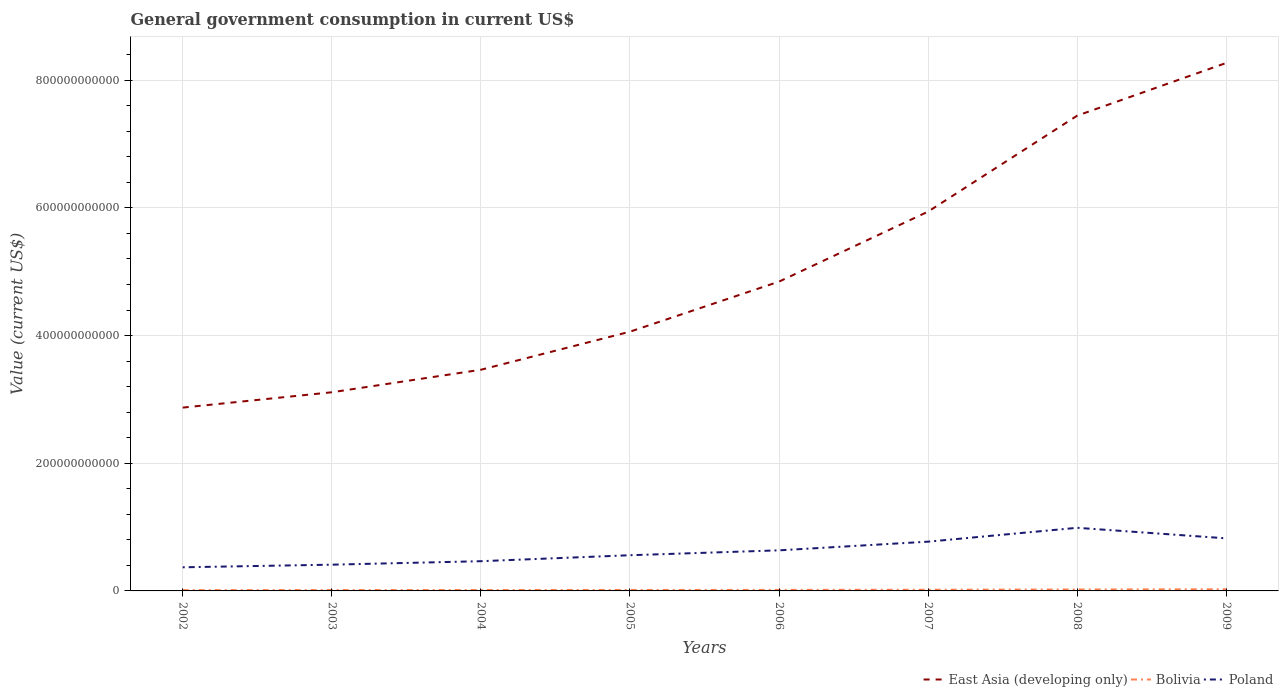Does the line corresponding to Poland intersect with the line corresponding to East Asia (developing only)?
Provide a succinct answer. No. Is the number of lines equal to the number of legend labels?
Your answer should be very brief. Yes. Across all years, what is the maximum government conusmption in East Asia (developing only)?
Your answer should be compact. 2.87e+11. What is the total government conusmption in Poland in the graph?
Provide a short and direct response. -1.89e+1. What is the difference between the highest and the second highest government conusmption in Poland?
Make the answer very short. 6.19e+1. How many years are there in the graph?
Offer a terse response. 8. What is the difference between two consecutive major ticks on the Y-axis?
Offer a terse response. 2.00e+11. Does the graph contain any zero values?
Provide a succinct answer. No. Does the graph contain grids?
Provide a succinct answer. Yes. Where does the legend appear in the graph?
Your answer should be compact. Bottom right. What is the title of the graph?
Offer a very short reply. General government consumption in current US$. Does "Guam" appear as one of the legend labels in the graph?
Offer a terse response. No. What is the label or title of the X-axis?
Provide a succinct answer. Years. What is the label or title of the Y-axis?
Your answer should be very brief. Value (current US$). What is the Value (current US$) in East Asia (developing only) in 2002?
Your answer should be very brief. 2.87e+11. What is the Value (current US$) of Bolivia in 2002?
Keep it short and to the point. 1.26e+09. What is the Value (current US$) in Poland in 2002?
Ensure brevity in your answer.  3.70e+1. What is the Value (current US$) in East Asia (developing only) in 2003?
Your answer should be compact. 3.11e+11. What is the Value (current US$) of Bolivia in 2003?
Give a very brief answer. 1.34e+09. What is the Value (current US$) of Poland in 2003?
Your answer should be compact. 4.11e+1. What is the Value (current US$) in East Asia (developing only) in 2004?
Keep it short and to the point. 3.46e+11. What is the Value (current US$) in Bolivia in 2004?
Your answer should be compact. 1.43e+09. What is the Value (current US$) of Poland in 2004?
Ensure brevity in your answer.  4.66e+1. What is the Value (current US$) in East Asia (developing only) in 2005?
Offer a terse response. 4.06e+11. What is the Value (current US$) of Bolivia in 2005?
Provide a short and direct response. 1.53e+09. What is the Value (current US$) of Poland in 2005?
Offer a very short reply. 5.59e+1. What is the Value (current US$) of East Asia (developing only) in 2006?
Make the answer very short. 4.85e+11. What is the Value (current US$) in Bolivia in 2006?
Provide a short and direct response. 1.64e+09. What is the Value (current US$) in Poland in 2006?
Provide a short and direct response. 6.36e+1. What is the Value (current US$) of East Asia (developing only) in 2007?
Give a very brief answer. 5.94e+11. What is the Value (current US$) of Bolivia in 2007?
Provide a short and direct response. 1.84e+09. What is the Value (current US$) in Poland in 2007?
Make the answer very short. 7.72e+1. What is the Value (current US$) in East Asia (developing only) in 2008?
Keep it short and to the point. 7.45e+11. What is the Value (current US$) of Bolivia in 2008?
Provide a short and direct response. 2.21e+09. What is the Value (current US$) in Poland in 2008?
Ensure brevity in your answer.  9.89e+1. What is the Value (current US$) in East Asia (developing only) in 2009?
Ensure brevity in your answer.  8.27e+11. What is the Value (current US$) of Bolivia in 2009?
Give a very brief answer. 2.55e+09. What is the Value (current US$) of Poland in 2009?
Keep it short and to the point. 8.24e+1. Across all years, what is the maximum Value (current US$) of East Asia (developing only)?
Make the answer very short. 8.27e+11. Across all years, what is the maximum Value (current US$) in Bolivia?
Ensure brevity in your answer.  2.55e+09. Across all years, what is the maximum Value (current US$) of Poland?
Give a very brief answer. 9.89e+1. Across all years, what is the minimum Value (current US$) of East Asia (developing only)?
Give a very brief answer. 2.87e+11. Across all years, what is the minimum Value (current US$) in Bolivia?
Offer a very short reply. 1.26e+09. Across all years, what is the minimum Value (current US$) of Poland?
Give a very brief answer. 3.70e+1. What is the total Value (current US$) in East Asia (developing only) in the graph?
Your answer should be very brief. 4.00e+12. What is the total Value (current US$) in Bolivia in the graph?
Give a very brief answer. 1.38e+1. What is the total Value (current US$) in Poland in the graph?
Ensure brevity in your answer.  5.03e+11. What is the difference between the Value (current US$) of East Asia (developing only) in 2002 and that in 2003?
Ensure brevity in your answer.  -2.40e+1. What is the difference between the Value (current US$) of Bolivia in 2002 and that in 2003?
Give a very brief answer. -7.30e+07. What is the difference between the Value (current US$) of Poland in 2002 and that in 2003?
Your answer should be compact. -4.10e+09. What is the difference between the Value (current US$) of East Asia (developing only) in 2002 and that in 2004?
Offer a terse response. -5.93e+1. What is the difference between the Value (current US$) in Bolivia in 2002 and that in 2004?
Make the answer very short. -1.64e+08. What is the difference between the Value (current US$) of Poland in 2002 and that in 2004?
Make the answer very short. -9.54e+09. What is the difference between the Value (current US$) in East Asia (developing only) in 2002 and that in 2005?
Offer a terse response. -1.19e+11. What is the difference between the Value (current US$) of Bolivia in 2002 and that in 2005?
Your answer should be compact. -2.63e+08. What is the difference between the Value (current US$) of Poland in 2002 and that in 2005?
Your answer should be compact. -1.89e+1. What is the difference between the Value (current US$) in East Asia (developing only) in 2002 and that in 2006?
Make the answer very short. -1.97e+11. What is the difference between the Value (current US$) in Bolivia in 2002 and that in 2006?
Make the answer very short. -3.81e+08. What is the difference between the Value (current US$) in Poland in 2002 and that in 2006?
Keep it short and to the point. -2.66e+1. What is the difference between the Value (current US$) of East Asia (developing only) in 2002 and that in 2007?
Your response must be concise. -3.07e+11. What is the difference between the Value (current US$) in Bolivia in 2002 and that in 2007?
Give a very brief answer. -5.82e+08. What is the difference between the Value (current US$) of Poland in 2002 and that in 2007?
Keep it short and to the point. -4.02e+1. What is the difference between the Value (current US$) of East Asia (developing only) in 2002 and that in 2008?
Your answer should be compact. -4.57e+11. What is the difference between the Value (current US$) in Bolivia in 2002 and that in 2008?
Provide a succinct answer. -9.52e+08. What is the difference between the Value (current US$) of Poland in 2002 and that in 2008?
Give a very brief answer. -6.19e+1. What is the difference between the Value (current US$) in East Asia (developing only) in 2002 and that in 2009?
Keep it short and to the point. -5.40e+11. What is the difference between the Value (current US$) in Bolivia in 2002 and that in 2009?
Keep it short and to the point. -1.29e+09. What is the difference between the Value (current US$) of Poland in 2002 and that in 2009?
Offer a very short reply. -4.53e+1. What is the difference between the Value (current US$) of East Asia (developing only) in 2003 and that in 2004?
Your answer should be very brief. -3.53e+1. What is the difference between the Value (current US$) in Bolivia in 2003 and that in 2004?
Offer a very short reply. -9.11e+07. What is the difference between the Value (current US$) of Poland in 2003 and that in 2004?
Provide a succinct answer. -5.44e+09. What is the difference between the Value (current US$) in East Asia (developing only) in 2003 and that in 2005?
Your answer should be compact. -9.49e+1. What is the difference between the Value (current US$) of Bolivia in 2003 and that in 2005?
Your response must be concise. -1.90e+08. What is the difference between the Value (current US$) of Poland in 2003 and that in 2005?
Provide a short and direct response. -1.48e+1. What is the difference between the Value (current US$) in East Asia (developing only) in 2003 and that in 2006?
Your response must be concise. -1.73e+11. What is the difference between the Value (current US$) in Bolivia in 2003 and that in 2006?
Your response must be concise. -3.09e+08. What is the difference between the Value (current US$) in Poland in 2003 and that in 2006?
Keep it short and to the point. -2.25e+1. What is the difference between the Value (current US$) in East Asia (developing only) in 2003 and that in 2007?
Ensure brevity in your answer.  -2.83e+11. What is the difference between the Value (current US$) in Bolivia in 2003 and that in 2007?
Make the answer very short. -5.09e+08. What is the difference between the Value (current US$) of Poland in 2003 and that in 2007?
Offer a very short reply. -3.61e+1. What is the difference between the Value (current US$) in East Asia (developing only) in 2003 and that in 2008?
Offer a terse response. -4.33e+11. What is the difference between the Value (current US$) in Bolivia in 2003 and that in 2008?
Keep it short and to the point. -8.79e+08. What is the difference between the Value (current US$) in Poland in 2003 and that in 2008?
Your response must be concise. -5.78e+1. What is the difference between the Value (current US$) in East Asia (developing only) in 2003 and that in 2009?
Provide a succinct answer. -5.16e+11. What is the difference between the Value (current US$) of Bolivia in 2003 and that in 2009?
Give a very brief answer. -1.22e+09. What is the difference between the Value (current US$) in Poland in 2003 and that in 2009?
Make the answer very short. -4.12e+1. What is the difference between the Value (current US$) in East Asia (developing only) in 2004 and that in 2005?
Your response must be concise. -5.97e+1. What is the difference between the Value (current US$) of Bolivia in 2004 and that in 2005?
Keep it short and to the point. -9.90e+07. What is the difference between the Value (current US$) in Poland in 2004 and that in 2005?
Provide a short and direct response. -9.35e+09. What is the difference between the Value (current US$) of East Asia (developing only) in 2004 and that in 2006?
Offer a very short reply. -1.38e+11. What is the difference between the Value (current US$) in Bolivia in 2004 and that in 2006?
Your response must be concise. -2.17e+08. What is the difference between the Value (current US$) of Poland in 2004 and that in 2006?
Provide a succinct answer. -1.70e+1. What is the difference between the Value (current US$) of East Asia (developing only) in 2004 and that in 2007?
Make the answer very short. -2.48e+11. What is the difference between the Value (current US$) in Bolivia in 2004 and that in 2007?
Your answer should be very brief. -4.18e+08. What is the difference between the Value (current US$) in Poland in 2004 and that in 2007?
Your answer should be very brief. -3.06e+1. What is the difference between the Value (current US$) of East Asia (developing only) in 2004 and that in 2008?
Provide a short and direct response. -3.98e+11. What is the difference between the Value (current US$) of Bolivia in 2004 and that in 2008?
Your answer should be very brief. -7.87e+08. What is the difference between the Value (current US$) in Poland in 2004 and that in 2008?
Make the answer very short. -5.23e+1. What is the difference between the Value (current US$) in East Asia (developing only) in 2004 and that in 2009?
Provide a succinct answer. -4.81e+11. What is the difference between the Value (current US$) in Bolivia in 2004 and that in 2009?
Your answer should be compact. -1.12e+09. What is the difference between the Value (current US$) in Poland in 2004 and that in 2009?
Make the answer very short. -3.58e+1. What is the difference between the Value (current US$) in East Asia (developing only) in 2005 and that in 2006?
Provide a short and direct response. -7.84e+1. What is the difference between the Value (current US$) of Bolivia in 2005 and that in 2006?
Keep it short and to the point. -1.18e+08. What is the difference between the Value (current US$) in Poland in 2005 and that in 2006?
Your answer should be compact. -7.67e+09. What is the difference between the Value (current US$) in East Asia (developing only) in 2005 and that in 2007?
Provide a short and direct response. -1.88e+11. What is the difference between the Value (current US$) in Bolivia in 2005 and that in 2007?
Your answer should be compact. -3.19e+08. What is the difference between the Value (current US$) in Poland in 2005 and that in 2007?
Your response must be concise. -2.13e+1. What is the difference between the Value (current US$) of East Asia (developing only) in 2005 and that in 2008?
Offer a very short reply. -3.38e+11. What is the difference between the Value (current US$) in Bolivia in 2005 and that in 2008?
Your response must be concise. -6.88e+08. What is the difference between the Value (current US$) of Poland in 2005 and that in 2008?
Give a very brief answer. -4.30e+1. What is the difference between the Value (current US$) in East Asia (developing only) in 2005 and that in 2009?
Provide a short and direct response. -4.21e+11. What is the difference between the Value (current US$) in Bolivia in 2005 and that in 2009?
Provide a short and direct response. -1.03e+09. What is the difference between the Value (current US$) in Poland in 2005 and that in 2009?
Offer a very short reply. -2.64e+1. What is the difference between the Value (current US$) of East Asia (developing only) in 2006 and that in 2007?
Ensure brevity in your answer.  -1.10e+11. What is the difference between the Value (current US$) of Bolivia in 2006 and that in 2007?
Provide a short and direct response. -2.01e+08. What is the difference between the Value (current US$) of Poland in 2006 and that in 2007?
Your answer should be compact. -1.36e+1. What is the difference between the Value (current US$) of East Asia (developing only) in 2006 and that in 2008?
Give a very brief answer. -2.60e+11. What is the difference between the Value (current US$) in Bolivia in 2006 and that in 2008?
Offer a very short reply. -5.70e+08. What is the difference between the Value (current US$) of Poland in 2006 and that in 2008?
Offer a terse response. -3.53e+1. What is the difference between the Value (current US$) in East Asia (developing only) in 2006 and that in 2009?
Give a very brief answer. -3.43e+11. What is the difference between the Value (current US$) of Bolivia in 2006 and that in 2009?
Provide a succinct answer. -9.07e+08. What is the difference between the Value (current US$) of Poland in 2006 and that in 2009?
Offer a terse response. -1.88e+1. What is the difference between the Value (current US$) in East Asia (developing only) in 2007 and that in 2008?
Make the answer very short. -1.50e+11. What is the difference between the Value (current US$) of Bolivia in 2007 and that in 2008?
Ensure brevity in your answer.  -3.69e+08. What is the difference between the Value (current US$) in Poland in 2007 and that in 2008?
Your answer should be compact. -2.17e+1. What is the difference between the Value (current US$) in East Asia (developing only) in 2007 and that in 2009?
Give a very brief answer. -2.33e+11. What is the difference between the Value (current US$) of Bolivia in 2007 and that in 2009?
Give a very brief answer. -7.06e+08. What is the difference between the Value (current US$) of Poland in 2007 and that in 2009?
Offer a terse response. -5.18e+09. What is the difference between the Value (current US$) in East Asia (developing only) in 2008 and that in 2009?
Give a very brief answer. -8.26e+1. What is the difference between the Value (current US$) of Bolivia in 2008 and that in 2009?
Give a very brief answer. -3.37e+08. What is the difference between the Value (current US$) in Poland in 2008 and that in 2009?
Make the answer very short. 1.65e+1. What is the difference between the Value (current US$) of East Asia (developing only) in 2002 and the Value (current US$) of Bolivia in 2003?
Make the answer very short. 2.86e+11. What is the difference between the Value (current US$) in East Asia (developing only) in 2002 and the Value (current US$) in Poland in 2003?
Your response must be concise. 2.46e+11. What is the difference between the Value (current US$) in Bolivia in 2002 and the Value (current US$) in Poland in 2003?
Offer a terse response. -3.99e+1. What is the difference between the Value (current US$) in East Asia (developing only) in 2002 and the Value (current US$) in Bolivia in 2004?
Ensure brevity in your answer.  2.86e+11. What is the difference between the Value (current US$) of East Asia (developing only) in 2002 and the Value (current US$) of Poland in 2004?
Offer a very short reply. 2.41e+11. What is the difference between the Value (current US$) in Bolivia in 2002 and the Value (current US$) in Poland in 2004?
Provide a short and direct response. -4.53e+1. What is the difference between the Value (current US$) of East Asia (developing only) in 2002 and the Value (current US$) of Bolivia in 2005?
Your answer should be compact. 2.86e+11. What is the difference between the Value (current US$) in East Asia (developing only) in 2002 and the Value (current US$) in Poland in 2005?
Offer a terse response. 2.31e+11. What is the difference between the Value (current US$) in Bolivia in 2002 and the Value (current US$) in Poland in 2005?
Make the answer very short. -5.46e+1. What is the difference between the Value (current US$) in East Asia (developing only) in 2002 and the Value (current US$) in Bolivia in 2006?
Offer a terse response. 2.86e+11. What is the difference between the Value (current US$) of East Asia (developing only) in 2002 and the Value (current US$) of Poland in 2006?
Your answer should be compact. 2.24e+11. What is the difference between the Value (current US$) of Bolivia in 2002 and the Value (current US$) of Poland in 2006?
Offer a very short reply. -6.23e+1. What is the difference between the Value (current US$) of East Asia (developing only) in 2002 and the Value (current US$) of Bolivia in 2007?
Your answer should be compact. 2.85e+11. What is the difference between the Value (current US$) in East Asia (developing only) in 2002 and the Value (current US$) in Poland in 2007?
Keep it short and to the point. 2.10e+11. What is the difference between the Value (current US$) of Bolivia in 2002 and the Value (current US$) of Poland in 2007?
Provide a succinct answer. -7.59e+1. What is the difference between the Value (current US$) of East Asia (developing only) in 2002 and the Value (current US$) of Bolivia in 2008?
Provide a succinct answer. 2.85e+11. What is the difference between the Value (current US$) in East Asia (developing only) in 2002 and the Value (current US$) in Poland in 2008?
Provide a short and direct response. 1.88e+11. What is the difference between the Value (current US$) of Bolivia in 2002 and the Value (current US$) of Poland in 2008?
Give a very brief answer. -9.76e+1. What is the difference between the Value (current US$) of East Asia (developing only) in 2002 and the Value (current US$) of Bolivia in 2009?
Keep it short and to the point. 2.85e+11. What is the difference between the Value (current US$) in East Asia (developing only) in 2002 and the Value (current US$) in Poland in 2009?
Make the answer very short. 2.05e+11. What is the difference between the Value (current US$) in Bolivia in 2002 and the Value (current US$) in Poland in 2009?
Your response must be concise. -8.11e+1. What is the difference between the Value (current US$) in East Asia (developing only) in 2003 and the Value (current US$) in Bolivia in 2004?
Provide a short and direct response. 3.10e+11. What is the difference between the Value (current US$) of East Asia (developing only) in 2003 and the Value (current US$) of Poland in 2004?
Give a very brief answer. 2.65e+11. What is the difference between the Value (current US$) in Bolivia in 2003 and the Value (current US$) in Poland in 2004?
Your response must be concise. -4.52e+1. What is the difference between the Value (current US$) of East Asia (developing only) in 2003 and the Value (current US$) of Bolivia in 2005?
Your answer should be very brief. 3.10e+11. What is the difference between the Value (current US$) in East Asia (developing only) in 2003 and the Value (current US$) in Poland in 2005?
Give a very brief answer. 2.55e+11. What is the difference between the Value (current US$) in Bolivia in 2003 and the Value (current US$) in Poland in 2005?
Ensure brevity in your answer.  -5.46e+1. What is the difference between the Value (current US$) of East Asia (developing only) in 2003 and the Value (current US$) of Bolivia in 2006?
Give a very brief answer. 3.10e+11. What is the difference between the Value (current US$) in East Asia (developing only) in 2003 and the Value (current US$) in Poland in 2006?
Offer a terse response. 2.48e+11. What is the difference between the Value (current US$) of Bolivia in 2003 and the Value (current US$) of Poland in 2006?
Your response must be concise. -6.22e+1. What is the difference between the Value (current US$) in East Asia (developing only) in 2003 and the Value (current US$) in Bolivia in 2007?
Your answer should be compact. 3.09e+11. What is the difference between the Value (current US$) in East Asia (developing only) in 2003 and the Value (current US$) in Poland in 2007?
Your response must be concise. 2.34e+11. What is the difference between the Value (current US$) of Bolivia in 2003 and the Value (current US$) of Poland in 2007?
Provide a succinct answer. -7.58e+1. What is the difference between the Value (current US$) in East Asia (developing only) in 2003 and the Value (current US$) in Bolivia in 2008?
Provide a succinct answer. 3.09e+11. What is the difference between the Value (current US$) in East Asia (developing only) in 2003 and the Value (current US$) in Poland in 2008?
Provide a short and direct response. 2.12e+11. What is the difference between the Value (current US$) of Bolivia in 2003 and the Value (current US$) of Poland in 2008?
Your response must be concise. -9.75e+1. What is the difference between the Value (current US$) in East Asia (developing only) in 2003 and the Value (current US$) in Bolivia in 2009?
Offer a very short reply. 3.09e+11. What is the difference between the Value (current US$) in East Asia (developing only) in 2003 and the Value (current US$) in Poland in 2009?
Your response must be concise. 2.29e+11. What is the difference between the Value (current US$) of Bolivia in 2003 and the Value (current US$) of Poland in 2009?
Your response must be concise. -8.10e+1. What is the difference between the Value (current US$) in East Asia (developing only) in 2004 and the Value (current US$) in Bolivia in 2005?
Give a very brief answer. 3.45e+11. What is the difference between the Value (current US$) of East Asia (developing only) in 2004 and the Value (current US$) of Poland in 2005?
Offer a very short reply. 2.91e+11. What is the difference between the Value (current US$) of Bolivia in 2004 and the Value (current US$) of Poland in 2005?
Your answer should be compact. -5.45e+1. What is the difference between the Value (current US$) in East Asia (developing only) in 2004 and the Value (current US$) in Bolivia in 2006?
Ensure brevity in your answer.  3.45e+11. What is the difference between the Value (current US$) in East Asia (developing only) in 2004 and the Value (current US$) in Poland in 2006?
Offer a very short reply. 2.83e+11. What is the difference between the Value (current US$) in Bolivia in 2004 and the Value (current US$) in Poland in 2006?
Your response must be concise. -6.22e+1. What is the difference between the Value (current US$) of East Asia (developing only) in 2004 and the Value (current US$) of Bolivia in 2007?
Keep it short and to the point. 3.45e+11. What is the difference between the Value (current US$) in East Asia (developing only) in 2004 and the Value (current US$) in Poland in 2007?
Provide a succinct answer. 2.69e+11. What is the difference between the Value (current US$) of Bolivia in 2004 and the Value (current US$) of Poland in 2007?
Offer a very short reply. -7.57e+1. What is the difference between the Value (current US$) in East Asia (developing only) in 2004 and the Value (current US$) in Bolivia in 2008?
Offer a terse response. 3.44e+11. What is the difference between the Value (current US$) of East Asia (developing only) in 2004 and the Value (current US$) of Poland in 2008?
Provide a succinct answer. 2.48e+11. What is the difference between the Value (current US$) in Bolivia in 2004 and the Value (current US$) in Poland in 2008?
Offer a terse response. -9.75e+1. What is the difference between the Value (current US$) in East Asia (developing only) in 2004 and the Value (current US$) in Bolivia in 2009?
Provide a succinct answer. 3.44e+11. What is the difference between the Value (current US$) of East Asia (developing only) in 2004 and the Value (current US$) of Poland in 2009?
Give a very brief answer. 2.64e+11. What is the difference between the Value (current US$) in Bolivia in 2004 and the Value (current US$) in Poland in 2009?
Make the answer very short. -8.09e+1. What is the difference between the Value (current US$) in East Asia (developing only) in 2005 and the Value (current US$) in Bolivia in 2006?
Provide a succinct answer. 4.04e+11. What is the difference between the Value (current US$) of East Asia (developing only) in 2005 and the Value (current US$) of Poland in 2006?
Offer a very short reply. 3.43e+11. What is the difference between the Value (current US$) of Bolivia in 2005 and the Value (current US$) of Poland in 2006?
Offer a very short reply. -6.21e+1. What is the difference between the Value (current US$) of East Asia (developing only) in 2005 and the Value (current US$) of Bolivia in 2007?
Give a very brief answer. 4.04e+11. What is the difference between the Value (current US$) of East Asia (developing only) in 2005 and the Value (current US$) of Poland in 2007?
Your response must be concise. 3.29e+11. What is the difference between the Value (current US$) in Bolivia in 2005 and the Value (current US$) in Poland in 2007?
Offer a very short reply. -7.57e+1. What is the difference between the Value (current US$) of East Asia (developing only) in 2005 and the Value (current US$) of Bolivia in 2008?
Your answer should be compact. 4.04e+11. What is the difference between the Value (current US$) of East Asia (developing only) in 2005 and the Value (current US$) of Poland in 2008?
Your answer should be very brief. 3.07e+11. What is the difference between the Value (current US$) in Bolivia in 2005 and the Value (current US$) in Poland in 2008?
Your answer should be very brief. -9.74e+1. What is the difference between the Value (current US$) of East Asia (developing only) in 2005 and the Value (current US$) of Bolivia in 2009?
Your answer should be compact. 4.04e+11. What is the difference between the Value (current US$) of East Asia (developing only) in 2005 and the Value (current US$) of Poland in 2009?
Provide a short and direct response. 3.24e+11. What is the difference between the Value (current US$) of Bolivia in 2005 and the Value (current US$) of Poland in 2009?
Make the answer very short. -8.08e+1. What is the difference between the Value (current US$) in East Asia (developing only) in 2006 and the Value (current US$) in Bolivia in 2007?
Your answer should be very brief. 4.83e+11. What is the difference between the Value (current US$) of East Asia (developing only) in 2006 and the Value (current US$) of Poland in 2007?
Offer a terse response. 4.07e+11. What is the difference between the Value (current US$) in Bolivia in 2006 and the Value (current US$) in Poland in 2007?
Your answer should be very brief. -7.55e+1. What is the difference between the Value (current US$) of East Asia (developing only) in 2006 and the Value (current US$) of Bolivia in 2008?
Make the answer very short. 4.82e+11. What is the difference between the Value (current US$) of East Asia (developing only) in 2006 and the Value (current US$) of Poland in 2008?
Your answer should be compact. 3.86e+11. What is the difference between the Value (current US$) of Bolivia in 2006 and the Value (current US$) of Poland in 2008?
Your answer should be compact. -9.72e+1. What is the difference between the Value (current US$) in East Asia (developing only) in 2006 and the Value (current US$) in Bolivia in 2009?
Your answer should be very brief. 4.82e+11. What is the difference between the Value (current US$) of East Asia (developing only) in 2006 and the Value (current US$) of Poland in 2009?
Offer a terse response. 4.02e+11. What is the difference between the Value (current US$) of Bolivia in 2006 and the Value (current US$) of Poland in 2009?
Give a very brief answer. -8.07e+1. What is the difference between the Value (current US$) in East Asia (developing only) in 2007 and the Value (current US$) in Bolivia in 2008?
Offer a terse response. 5.92e+11. What is the difference between the Value (current US$) in East Asia (developing only) in 2007 and the Value (current US$) in Poland in 2008?
Provide a short and direct response. 4.95e+11. What is the difference between the Value (current US$) of Bolivia in 2007 and the Value (current US$) of Poland in 2008?
Your answer should be compact. -9.70e+1. What is the difference between the Value (current US$) in East Asia (developing only) in 2007 and the Value (current US$) in Bolivia in 2009?
Offer a terse response. 5.92e+11. What is the difference between the Value (current US$) of East Asia (developing only) in 2007 and the Value (current US$) of Poland in 2009?
Your response must be concise. 5.12e+11. What is the difference between the Value (current US$) of Bolivia in 2007 and the Value (current US$) of Poland in 2009?
Make the answer very short. -8.05e+1. What is the difference between the Value (current US$) in East Asia (developing only) in 2008 and the Value (current US$) in Bolivia in 2009?
Provide a short and direct response. 7.42e+11. What is the difference between the Value (current US$) of East Asia (developing only) in 2008 and the Value (current US$) of Poland in 2009?
Your answer should be very brief. 6.62e+11. What is the difference between the Value (current US$) in Bolivia in 2008 and the Value (current US$) in Poland in 2009?
Provide a succinct answer. -8.01e+1. What is the average Value (current US$) of East Asia (developing only) per year?
Provide a succinct answer. 5.00e+11. What is the average Value (current US$) in Bolivia per year?
Keep it short and to the point. 1.73e+09. What is the average Value (current US$) in Poland per year?
Ensure brevity in your answer.  6.28e+1. In the year 2002, what is the difference between the Value (current US$) in East Asia (developing only) and Value (current US$) in Bolivia?
Provide a succinct answer. 2.86e+11. In the year 2002, what is the difference between the Value (current US$) of East Asia (developing only) and Value (current US$) of Poland?
Offer a terse response. 2.50e+11. In the year 2002, what is the difference between the Value (current US$) of Bolivia and Value (current US$) of Poland?
Your answer should be compact. -3.58e+1. In the year 2003, what is the difference between the Value (current US$) in East Asia (developing only) and Value (current US$) in Bolivia?
Offer a terse response. 3.10e+11. In the year 2003, what is the difference between the Value (current US$) in East Asia (developing only) and Value (current US$) in Poland?
Offer a very short reply. 2.70e+11. In the year 2003, what is the difference between the Value (current US$) in Bolivia and Value (current US$) in Poland?
Offer a very short reply. -3.98e+1. In the year 2004, what is the difference between the Value (current US$) in East Asia (developing only) and Value (current US$) in Bolivia?
Keep it short and to the point. 3.45e+11. In the year 2004, what is the difference between the Value (current US$) in East Asia (developing only) and Value (current US$) in Poland?
Offer a terse response. 3.00e+11. In the year 2004, what is the difference between the Value (current US$) of Bolivia and Value (current US$) of Poland?
Your answer should be very brief. -4.51e+1. In the year 2005, what is the difference between the Value (current US$) in East Asia (developing only) and Value (current US$) in Bolivia?
Offer a very short reply. 4.05e+11. In the year 2005, what is the difference between the Value (current US$) in East Asia (developing only) and Value (current US$) in Poland?
Keep it short and to the point. 3.50e+11. In the year 2005, what is the difference between the Value (current US$) of Bolivia and Value (current US$) of Poland?
Provide a succinct answer. -5.44e+1. In the year 2006, what is the difference between the Value (current US$) of East Asia (developing only) and Value (current US$) of Bolivia?
Your answer should be very brief. 4.83e+11. In the year 2006, what is the difference between the Value (current US$) of East Asia (developing only) and Value (current US$) of Poland?
Make the answer very short. 4.21e+11. In the year 2006, what is the difference between the Value (current US$) of Bolivia and Value (current US$) of Poland?
Your response must be concise. -6.19e+1. In the year 2007, what is the difference between the Value (current US$) in East Asia (developing only) and Value (current US$) in Bolivia?
Make the answer very short. 5.92e+11. In the year 2007, what is the difference between the Value (current US$) of East Asia (developing only) and Value (current US$) of Poland?
Make the answer very short. 5.17e+11. In the year 2007, what is the difference between the Value (current US$) of Bolivia and Value (current US$) of Poland?
Your answer should be compact. -7.53e+1. In the year 2008, what is the difference between the Value (current US$) of East Asia (developing only) and Value (current US$) of Bolivia?
Ensure brevity in your answer.  7.42e+11. In the year 2008, what is the difference between the Value (current US$) in East Asia (developing only) and Value (current US$) in Poland?
Ensure brevity in your answer.  6.46e+11. In the year 2008, what is the difference between the Value (current US$) of Bolivia and Value (current US$) of Poland?
Provide a succinct answer. -9.67e+1. In the year 2009, what is the difference between the Value (current US$) of East Asia (developing only) and Value (current US$) of Bolivia?
Give a very brief answer. 8.25e+11. In the year 2009, what is the difference between the Value (current US$) in East Asia (developing only) and Value (current US$) in Poland?
Your answer should be very brief. 7.45e+11. In the year 2009, what is the difference between the Value (current US$) in Bolivia and Value (current US$) in Poland?
Provide a short and direct response. -7.98e+1. What is the ratio of the Value (current US$) in East Asia (developing only) in 2002 to that in 2003?
Ensure brevity in your answer.  0.92. What is the ratio of the Value (current US$) of Bolivia in 2002 to that in 2003?
Keep it short and to the point. 0.95. What is the ratio of the Value (current US$) in Poland in 2002 to that in 2003?
Provide a succinct answer. 0.9. What is the ratio of the Value (current US$) of East Asia (developing only) in 2002 to that in 2004?
Make the answer very short. 0.83. What is the ratio of the Value (current US$) of Bolivia in 2002 to that in 2004?
Provide a succinct answer. 0.89. What is the ratio of the Value (current US$) of Poland in 2002 to that in 2004?
Your answer should be very brief. 0.8. What is the ratio of the Value (current US$) of East Asia (developing only) in 2002 to that in 2005?
Provide a short and direct response. 0.71. What is the ratio of the Value (current US$) of Bolivia in 2002 to that in 2005?
Make the answer very short. 0.83. What is the ratio of the Value (current US$) of Poland in 2002 to that in 2005?
Provide a succinct answer. 0.66. What is the ratio of the Value (current US$) of East Asia (developing only) in 2002 to that in 2006?
Provide a succinct answer. 0.59. What is the ratio of the Value (current US$) of Bolivia in 2002 to that in 2006?
Provide a short and direct response. 0.77. What is the ratio of the Value (current US$) in Poland in 2002 to that in 2006?
Provide a succinct answer. 0.58. What is the ratio of the Value (current US$) of East Asia (developing only) in 2002 to that in 2007?
Your answer should be compact. 0.48. What is the ratio of the Value (current US$) of Bolivia in 2002 to that in 2007?
Your response must be concise. 0.68. What is the ratio of the Value (current US$) in Poland in 2002 to that in 2007?
Your response must be concise. 0.48. What is the ratio of the Value (current US$) of East Asia (developing only) in 2002 to that in 2008?
Make the answer very short. 0.39. What is the ratio of the Value (current US$) of Bolivia in 2002 to that in 2008?
Ensure brevity in your answer.  0.57. What is the ratio of the Value (current US$) in Poland in 2002 to that in 2008?
Provide a short and direct response. 0.37. What is the ratio of the Value (current US$) in East Asia (developing only) in 2002 to that in 2009?
Make the answer very short. 0.35. What is the ratio of the Value (current US$) of Bolivia in 2002 to that in 2009?
Offer a very short reply. 0.49. What is the ratio of the Value (current US$) in Poland in 2002 to that in 2009?
Your answer should be compact. 0.45. What is the ratio of the Value (current US$) of East Asia (developing only) in 2003 to that in 2004?
Keep it short and to the point. 0.9. What is the ratio of the Value (current US$) of Bolivia in 2003 to that in 2004?
Make the answer very short. 0.94. What is the ratio of the Value (current US$) of Poland in 2003 to that in 2004?
Provide a short and direct response. 0.88. What is the ratio of the Value (current US$) in East Asia (developing only) in 2003 to that in 2005?
Your response must be concise. 0.77. What is the ratio of the Value (current US$) of Bolivia in 2003 to that in 2005?
Keep it short and to the point. 0.88. What is the ratio of the Value (current US$) of Poland in 2003 to that in 2005?
Offer a very short reply. 0.74. What is the ratio of the Value (current US$) of East Asia (developing only) in 2003 to that in 2006?
Your answer should be very brief. 0.64. What is the ratio of the Value (current US$) in Bolivia in 2003 to that in 2006?
Your response must be concise. 0.81. What is the ratio of the Value (current US$) of Poland in 2003 to that in 2006?
Make the answer very short. 0.65. What is the ratio of the Value (current US$) of East Asia (developing only) in 2003 to that in 2007?
Ensure brevity in your answer.  0.52. What is the ratio of the Value (current US$) of Bolivia in 2003 to that in 2007?
Offer a terse response. 0.72. What is the ratio of the Value (current US$) in Poland in 2003 to that in 2007?
Provide a succinct answer. 0.53. What is the ratio of the Value (current US$) in East Asia (developing only) in 2003 to that in 2008?
Give a very brief answer. 0.42. What is the ratio of the Value (current US$) in Bolivia in 2003 to that in 2008?
Your answer should be very brief. 0.6. What is the ratio of the Value (current US$) in Poland in 2003 to that in 2008?
Ensure brevity in your answer.  0.42. What is the ratio of the Value (current US$) of East Asia (developing only) in 2003 to that in 2009?
Offer a very short reply. 0.38. What is the ratio of the Value (current US$) of Bolivia in 2003 to that in 2009?
Offer a very short reply. 0.52. What is the ratio of the Value (current US$) of Poland in 2003 to that in 2009?
Provide a short and direct response. 0.5. What is the ratio of the Value (current US$) in East Asia (developing only) in 2004 to that in 2005?
Provide a succinct answer. 0.85. What is the ratio of the Value (current US$) in Bolivia in 2004 to that in 2005?
Ensure brevity in your answer.  0.94. What is the ratio of the Value (current US$) of Poland in 2004 to that in 2005?
Provide a short and direct response. 0.83. What is the ratio of the Value (current US$) in East Asia (developing only) in 2004 to that in 2006?
Your answer should be very brief. 0.71. What is the ratio of the Value (current US$) of Bolivia in 2004 to that in 2006?
Your response must be concise. 0.87. What is the ratio of the Value (current US$) in Poland in 2004 to that in 2006?
Provide a succinct answer. 0.73. What is the ratio of the Value (current US$) of East Asia (developing only) in 2004 to that in 2007?
Provide a succinct answer. 0.58. What is the ratio of the Value (current US$) in Bolivia in 2004 to that in 2007?
Your answer should be very brief. 0.77. What is the ratio of the Value (current US$) of Poland in 2004 to that in 2007?
Your response must be concise. 0.6. What is the ratio of the Value (current US$) in East Asia (developing only) in 2004 to that in 2008?
Your answer should be very brief. 0.47. What is the ratio of the Value (current US$) in Bolivia in 2004 to that in 2008?
Your answer should be compact. 0.64. What is the ratio of the Value (current US$) in Poland in 2004 to that in 2008?
Offer a very short reply. 0.47. What is the ratio of the Value (current US$) in East Asia (developing only) in 2004 to that in 2009?
Make the answer very short. 0.42. What is the ratio of the Value (current US$) of Bolivia in 2004 to that in 2009?
Keep it short and to the point. 0.56. What is the ratio of the Value (current US$) in Poland in 2004 to that in 2009?
Give a very brief answer. 0.57. What is the ratio of the Value (current US$) in East Asia (developing only) in 2005 to that in 2006?
Offer a very short reply. 0.84. What is the ratio of the Value (current US$) of Bolivia in 2005 to that in 2006?
Offer a terse response. 0.93. What is the ratio of the Value (current US$) of Poland in 2005 to that in 2006?
Provide a succinct answer. 0.88. What is the ratio of the Value (current US$) in East Asia (developing only) in 2005 to that in 2007?
Your answer should be very brief. 0.68. What is the ratio of the Value (current US$) in Bolivia in 2005 to that in 2007?
Provide a succinct answer. 0.83. What is the ratio of the Value (current US$) of Poland in 2005 to that in 2007?
Provide a succinct answer. 0.72. What is the ratio of the Value (current US$) of East Asia (developing only) in 2005 to that in 2008?
Offer a very short reply. 0.55. What is the ratio of the Value (current US$) in Bolivia in 2005 to that in 2008?
Your response must be concise. 0.69. What is the ratio of the Value (current US$) of Poland in 2005 to that in 2008?
Provide a short and direct response. 0.57. What is the ratio of the Value (current US$) in East Asia (developing only) in 2005 to that in 2009?
Offer a very short reply. 0.49. What is the ratio of the Value (current US$) of Bolivia in 2005 to that in 2009?
Your response must be concise. 0.6. What is the ratio of the Value (current US$) of Poland in 2005 to that in 2009?
Provide a succinct answer. 0.68. What is the ratio of the Value (current US$) in East Asia (developing only) in 2006 to that in 2007?
Your answer should be compact. 0.82. What is the ratio of the Value (current US$) of Bolivia in 2006 to that in 2007?
Provide a short and direct response. 0.89. What is the ratio of the Value (current US$) in Poland in 2006 to that in 2007?
Give a very brief answer. 0.82. What is the ratio of the Value (current US$) of East Asia (developing only) in 2006 to that in 2008?
Give a very brief answer. 0.65. What is the ratio of the Value (current US$) of Bolivia in 2006 to that in 2008?
Your response must be concise. 0.74. What is the ratio of the Value (current US$) in Poland in 2006 to that in 2008?
Offer a very short reply. 0.64. What is the ratio of the Value (current US$) in East Asia (developing only) in 2006 to that in 2009?
Your answer should be compact. 0.59. What is the ratio of the Value (current US$) in Bolivia in 2006 to that in 2009?
Your answer should be very brief. 0.64. What is the ratio of the Value (current US$) in Poland in 2006 to that in 2009?
Keep it short and to the point. 0.77. What is the ratio of the Value (current US$) of East Asia (developing only) in 2007 to that in 2008?
Your answer should be compact. 0.8. What is the ratio of the Value (current US$) of Bolivia in 2007 to that in 2008?
Make the answer very short. 0.83. What is the ratio of the Value (current US$) in Poland in 2007 to that in 2008?
Provide a short and direct response. 0.78. What is the ratio of the Value (current US$) in East Asia (developing only) in 2007 to that in 2009?
Ensure brevity in your answer.  0.72. What is the ratio of the Value (current US$) in Bolivia in 2007 to that in 2009?
Ensure brevity in your answer.  0.72. What is the ratio of the Value (current US$) of Poland in 2007 to that in 2009?
Your answer should be very brief. 0.94. What is the ratio of the Value (current US$) of East Asia (developing only) in 2008 to that in 2009?
Your response must be concise. 0.9. What is the ratio of the Value (current US$) in Bolivia in 2008 to that in 2009?
Your answer should be very brief. 0.87. What is the ratio of the Value (current US$) of Poland in 2008 to that in 2009?
Provide a short and direct response. 1.2. What is the difference between the highest and the second highest Value (current US$) in East Asia (developing only)?
Provide a short and direct response. 8.26e+1. What is the difference between the highest and the second highest Value (current US$) in Bolivia?
Your response must be concise. 3.37e+08. What is the difference between the highest and the second highest Value (current US$) of Poland?
Ensure brevity in your answer.  1.65e+1. What is the difference between the highest and the lowest Value (current US$) in East Asia (developing only)?
Your answer should be compact. 5.40e+11. What is the difference between the highest and the lowest Value (current US$) of Bolivia?
Your response must be concise. 1.29e+09. What is the difference between the highest and the lowest Value (current US$) in Poland?
Offer a terse response. 6.19e+1. 